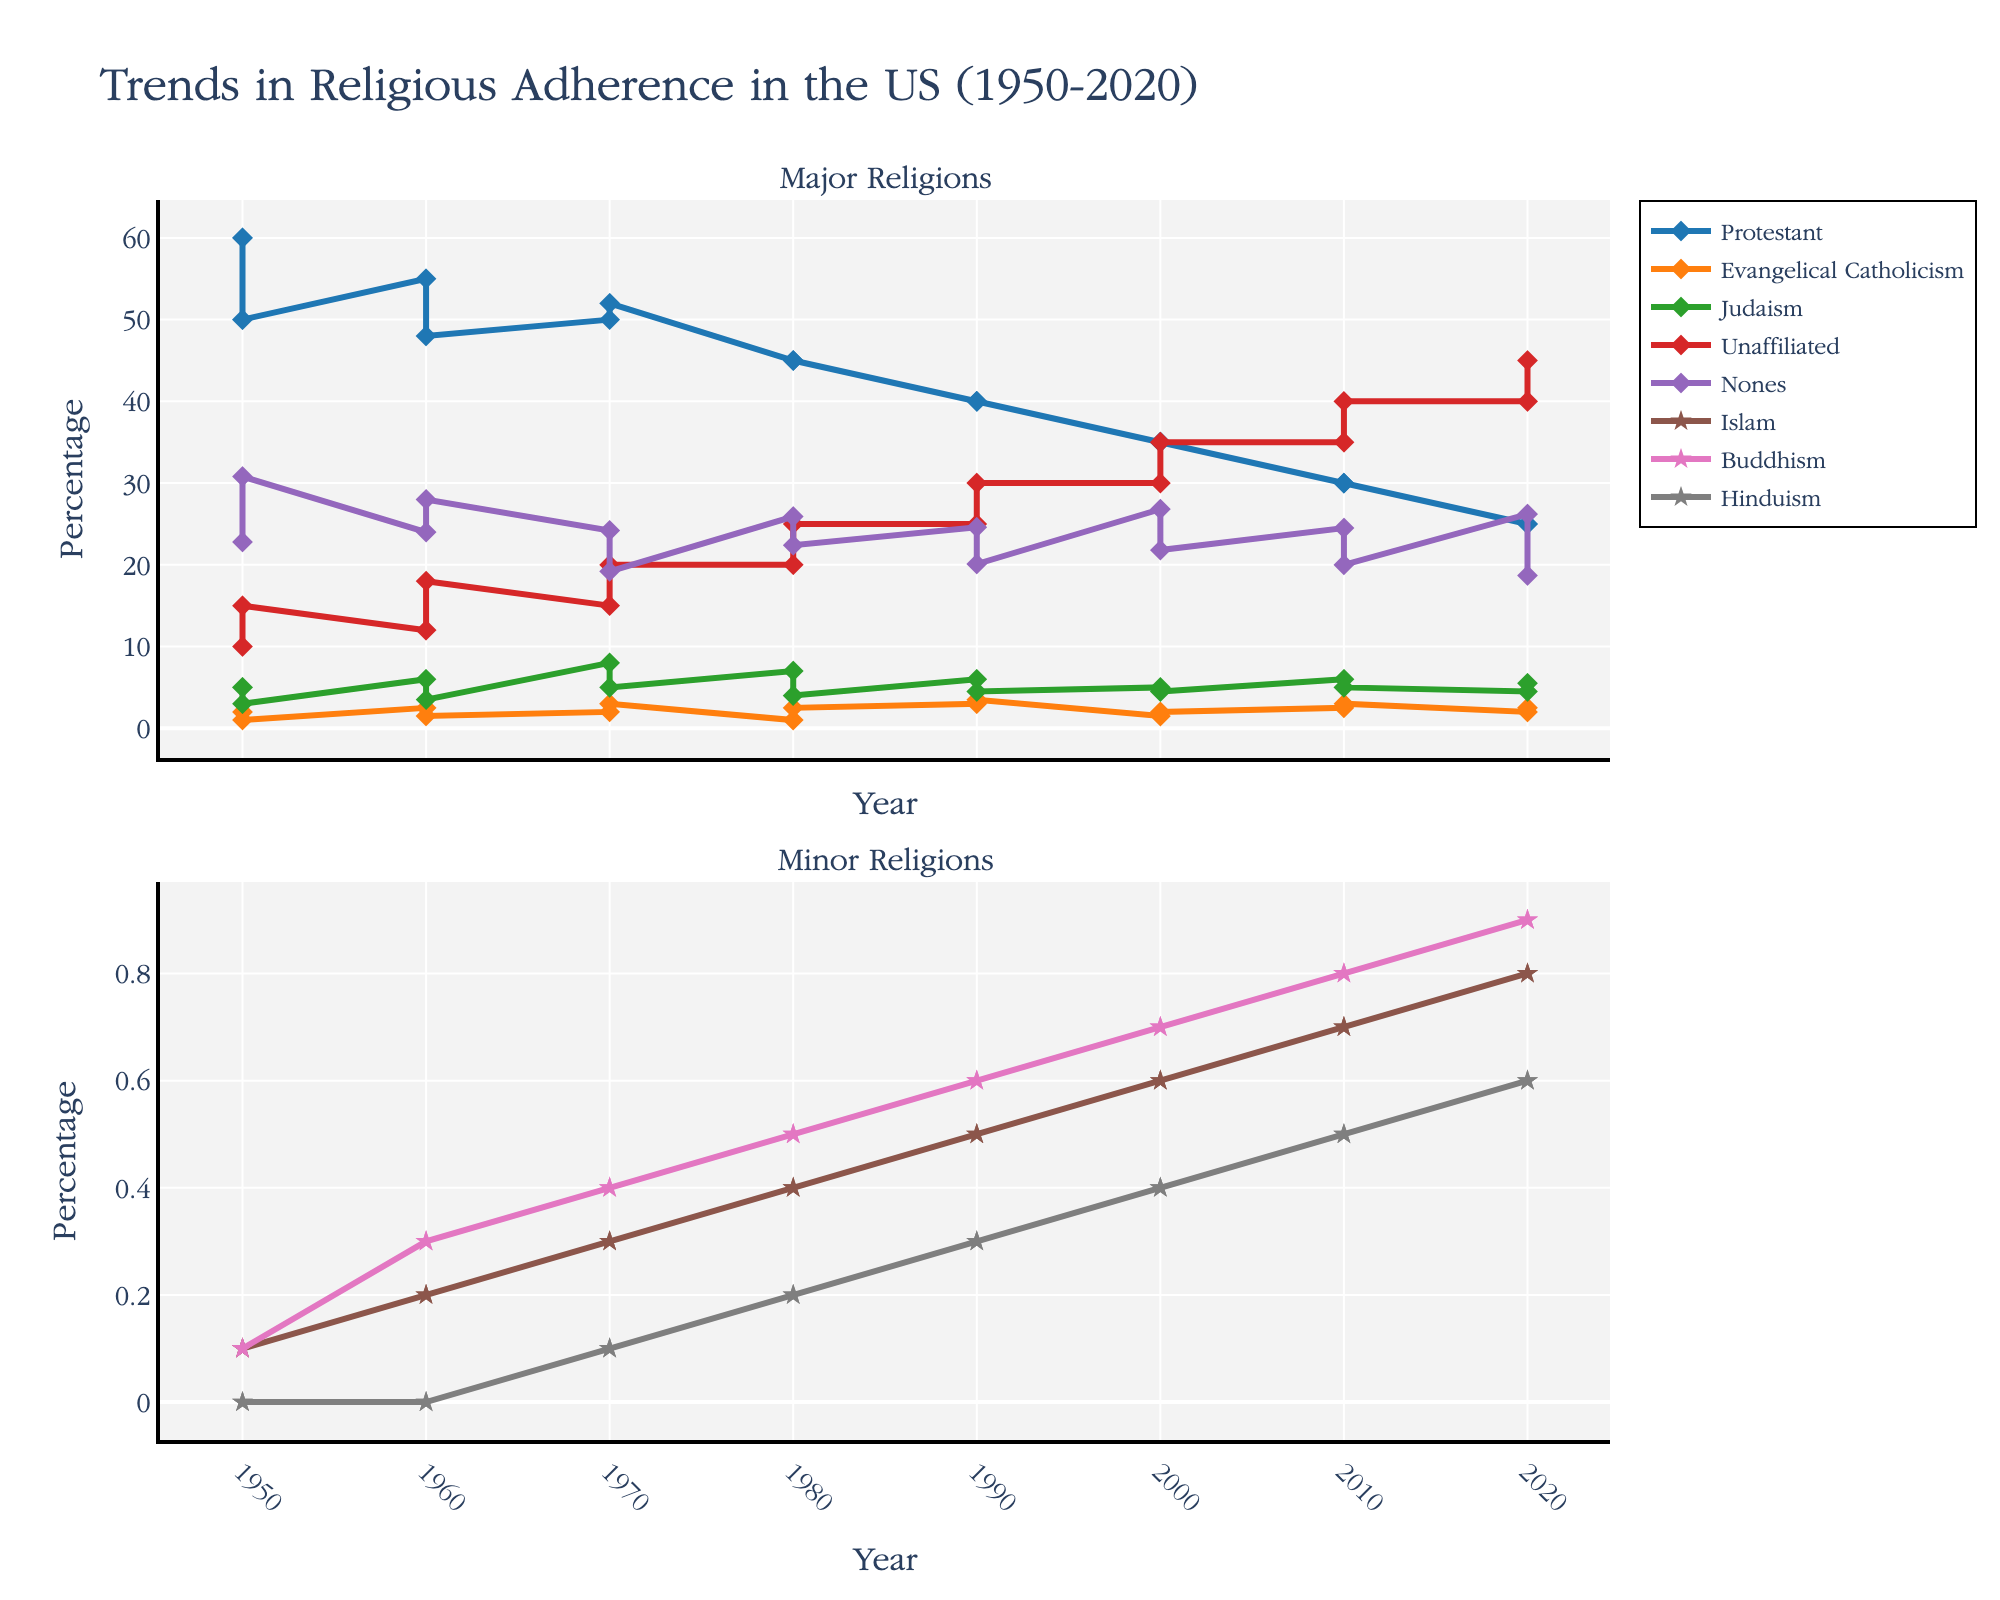What's the title of the figure? The title is usually located at the top of the figure and provides a concise description of what the figure represents. In this case, the title is "Trends in Religious Adherence in the US (1950-2020)".
Answer: Trends in Religious Adherence in the US (1950-2020) Which major religion has shown the most notable decline from 1950 to 2020? By looking at the lines representing major religions in the first subplot, you can see which one has the steepest downward trend. Protestant adherence declines notably from around 60% to 25%.
Answer: Protestant What is the difference in the percentage of people who identify as Protestant and those who identify as unaffiliated in 2020? Find the values for Protestant and Unaffiliated in 2020, which are 25% and 40% respectively, and subtract the Protestant value from the Unaffiliated value: 40 - 25 = 15
Answer: 15 Which minor religion shows the highest increase over the time period? By examining the lines in the second subplot that represent minor religions, you can see which line increases the most. Islam shows a steady increase from 0.1% to 0.8%.
Answer: Islam How does the trend of individuals identifying as "Nones" change from 1950 to 2020? By looking at the line representing Nones, you can track the increasing trend, where it rises from 22.8% in 1950 to 26.2% in 2020.
Answer: It increases In which decade does the significant growth in unaffiliated identify begin? By observing the subplot for major religions, note when the Unaffiliated category starts to show a marked increase in the slope of the line. It begins its significant growth in the 1980s.
Answer: 1980s Compare the trends in Evangelical Catholicism and Buddhism between 1950 and 2020. Which has grown more? Consider the slopes of the lines for Evangelical Catholicism and Buddhism. Evangelical Catholicism rises from 2% to 2.5%, and Buddhism rises from 0.1% to 0.9%. Buddhism has grown more.
Answer: Buddhism Which ethnicity shows the highest adherence to Protestantism in every recorded year? By cross-referencing the Ethnicity data points on the time series plot, it is evident that the White ethnicity consistently has the highest Protestant adherence.
Answer: White 